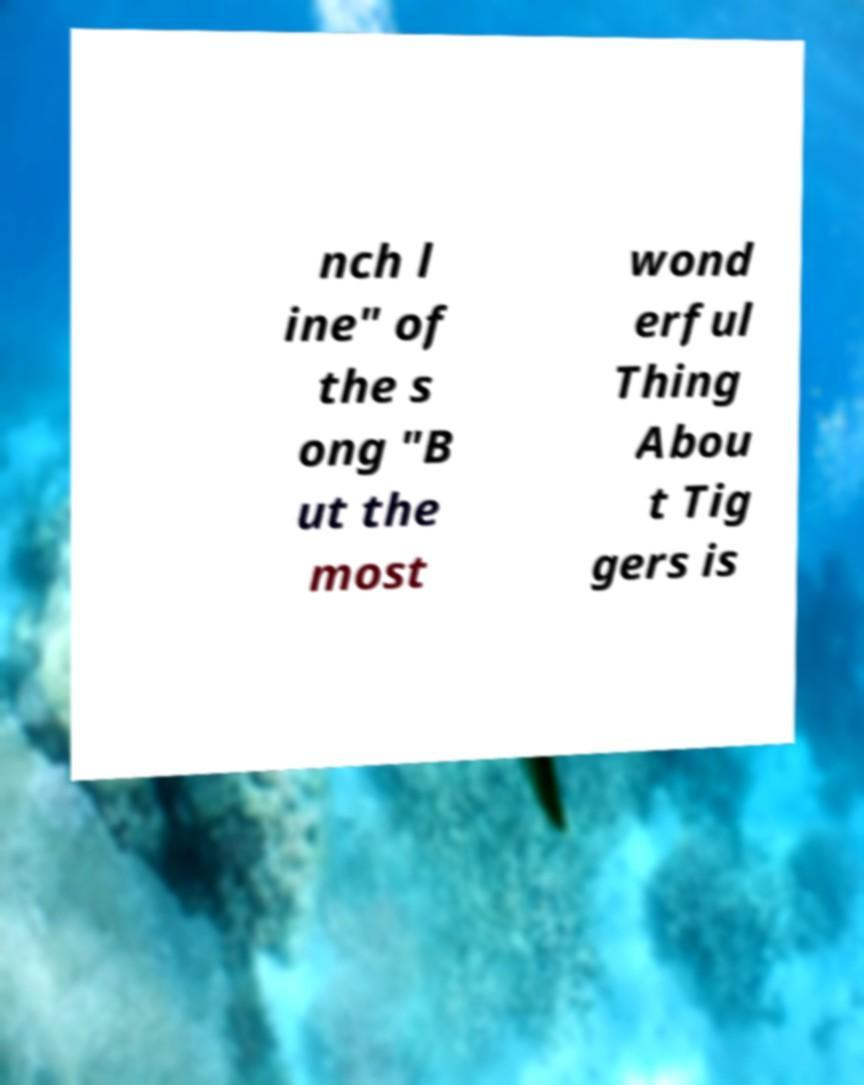Could you assist in decoding the text presented in this image and type it out clearly? nch l ine" of the s ong "B ut the most wond erful Thing Abou t Tig gers is 